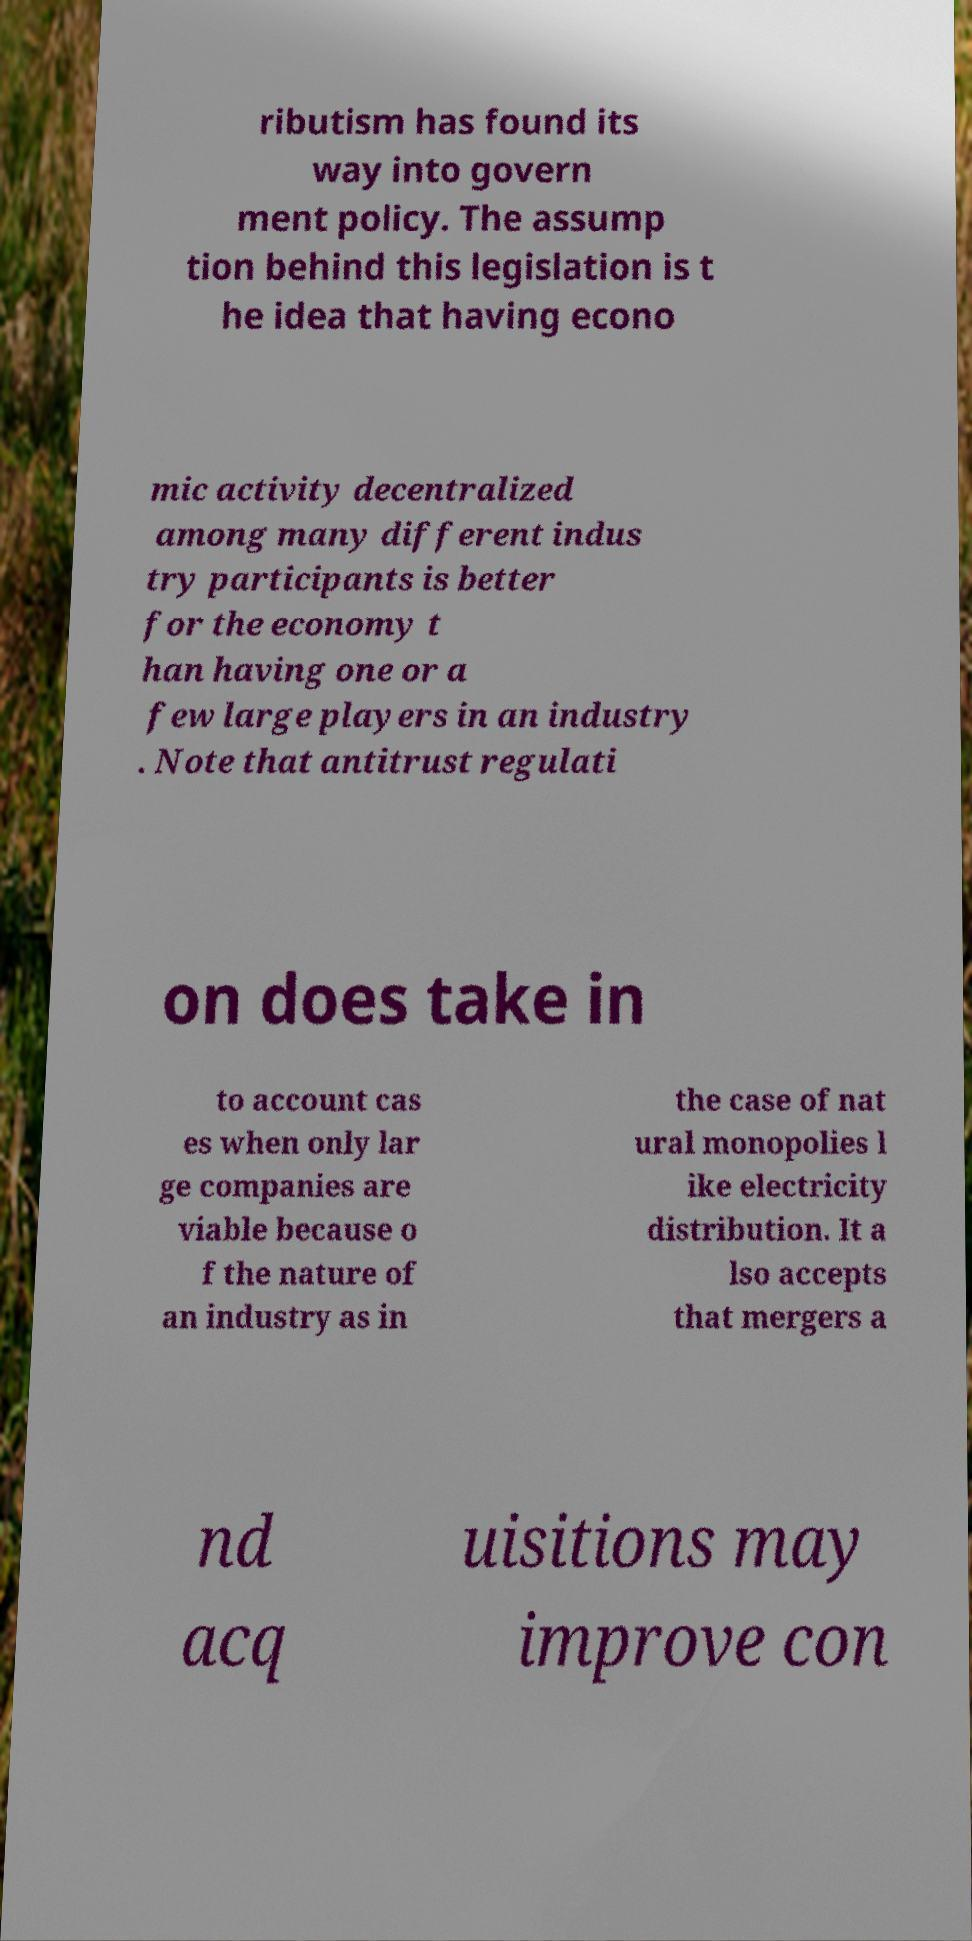What messages or text are displayed in this image? I need them in a readable, typed format. ributism has found its way into govern ment policy. The assump tion behind this legislation is t he idea that having econo mic activity decentralized among many different indus try participants is better for the economy t han having one or a few large players in an industry . Note that antitrust regulati on does take in to account cas es when only lar ge companies are viable because o f the nature of an industry as in the case of nat ural monopolies l ike electricity distribution. It a lso accepts that mergers a nd acq uisitions may improve con 